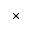Convert formula to latex. <formula><loc_0><loc_0><loc_500><loc_500>\times</formula> 